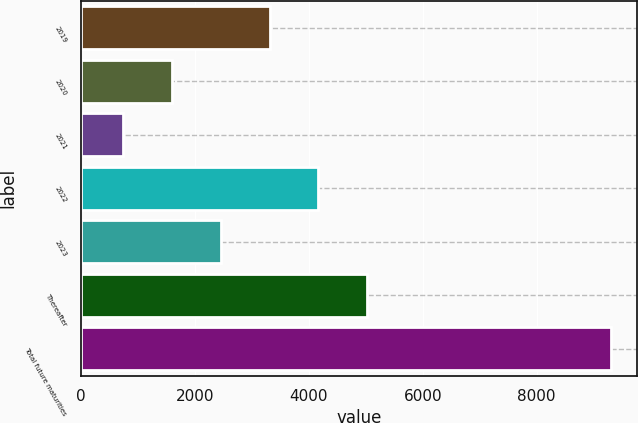Convert chart. <chart><loc_0><loc_0><loc_500><loc_500><bar_chart><fcel>2019<fcel>2020<fcel>2021<fcel>2022<fcel>2023<fcel>Thereafter<fcel>Total future maturities<nl><fcel>3315<fcel>1605<fcel>750<fcel>4170<fcel>2460<fcel>5025<fcel>9300<nl></chart> 